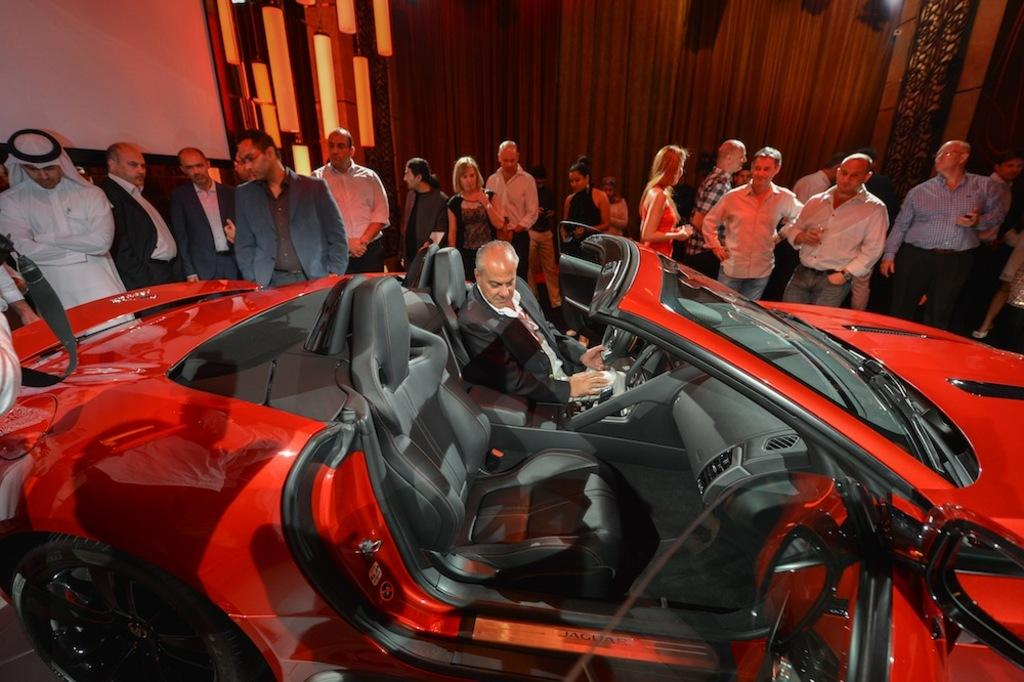What is the man in the image doing? The man is sitting in a car. What can be seen around the car in the image? There is a group of people standing around the car. What type of punishment is the man receiving from the group of people in the image? There is no indication in the image that the man is receiving any punishment from the group of people. 